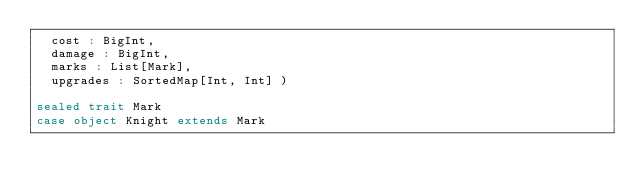Convert code to text. <code><loc_0><loc_0><loc_500><loc_500><_Scala_>  cost : BigInt,
  damage : BigInt,
  marks : List[Mark],
  upgrades : SortedMap[Int, Int] )

sealed trait Mark
case object Knight extends Mark
</code> 